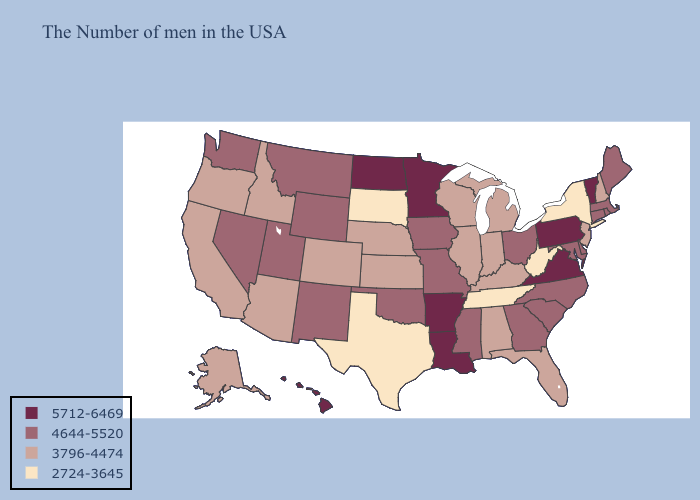Is the legend a continuous bar?
Short answer required. No. Name the states that have a value in the range 4644-5520?
Concise answer only. Maine, Massachusetts, Rhode Island, Connecticut, Delaware, Maryland, North Carolina, South Carolina, Ohio, Georgia, Mississippi, Missouri, Iowa, Oklahoma, Wyoming, New Mexico, Utah, Montana, Nevada, Washington. What is the highest value in states that border Colorado?
Short answer required. 4644-5520. Does Wyoming have the lowest value in the West?
Concise answer only. No. Which states have the highest value in the USA?
Answer briefly. Vermont, Pennsylvania, Virginia, Louisiana, Arkansas, Minnesota, North Dakota, Hawaii. What is the highest value in states that border West Virginia?
Give a very brief answer. 5712-6469. What is the value of Ohio?
Answer briefly. 4644-5520. What is the value of Minnesota?
Keep it brief. 5712-6469. Is the legend a continuous bar?
Quick response, please. No. What is the lowest value in the USA?
Be succinct. 2724-3645. Does the map have missing data?
Concise answer only. No. Name the states that have a value in the range 2724-3645?
Be succinct. New York, West Virginia, Tennessee, Texas, South Dakota. Does the map have missing data?
Give a very brief answer. No. Name the states that have a value in the range 5712-6469?
Short answer required. Vermont, Pennsylvania, Virginia, Louisiana, Arkansas, Minnesota, North Dakota, Hawaii. 